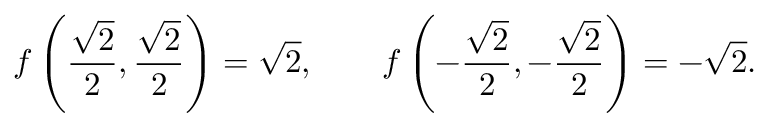Convert formula to latex. <formula><loc_0><loc_0><loc_500><loc_500>f \left ( { \frac { \sqrt { 2 } } { 2 } } , { \frac { \sqrt { 2 } } { 2 } } \right ) = { \sqrt { 2 } } , \quad f \left ( - { \frac { \sqrt { 2 } } { 2 } } , - { \frac { \sqrt { 2 } } { 2 } } \right ) = - { \sqrt { 2 } } .</formula> 